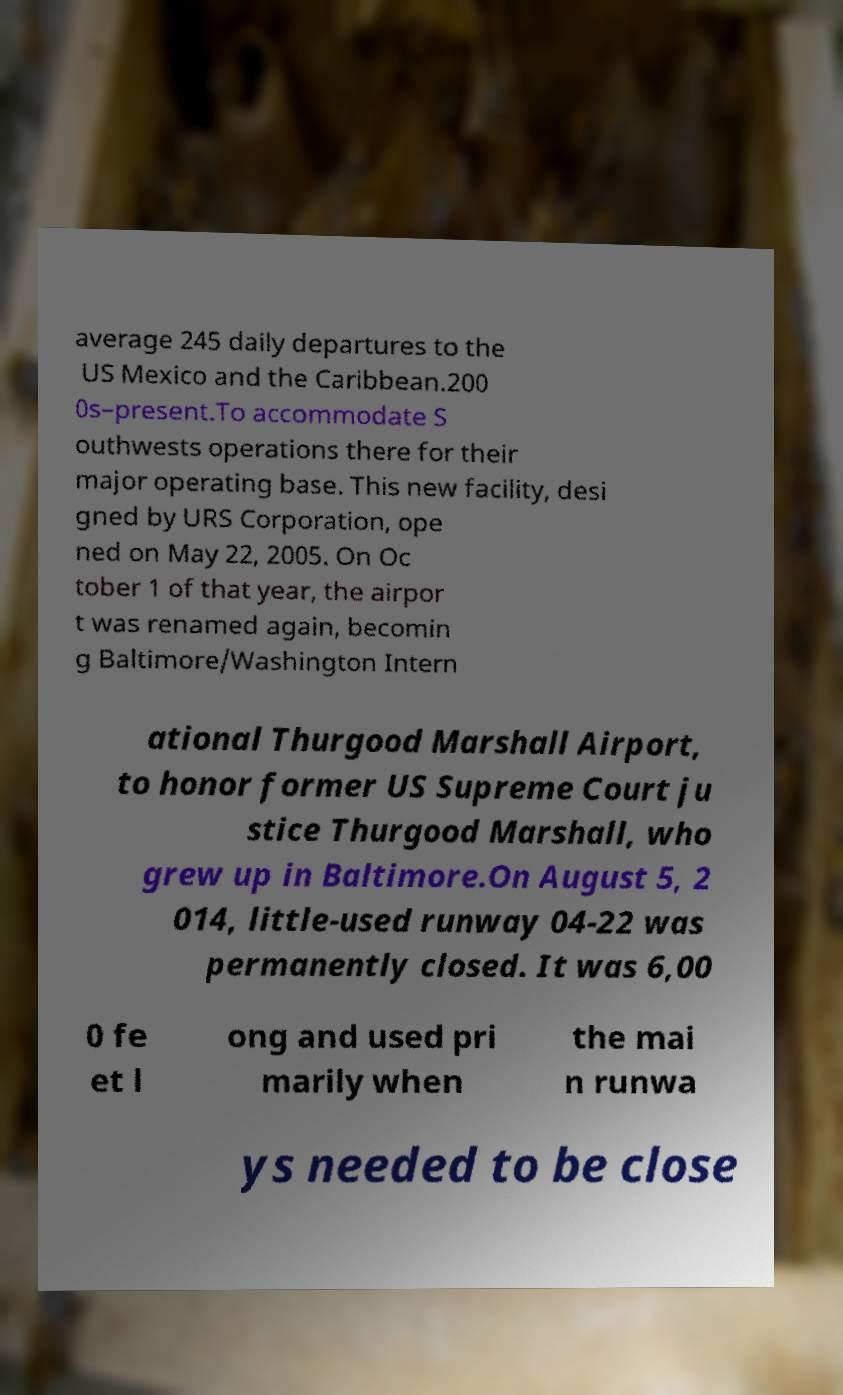Can you accurately transcribe the text from the provided image for me? average 245 daily departures to the US Mexico and the Caribbean.200 0s–present.To accommodate S outhwests operations there for their major operating base. This new facility, desi gned by URS Corporation, ope ned on May 22, 2005. On Oc tober 1 of that year, the airpor t was renamed again, becomin g Baltimore/Washington Intern ational Thurgood Marshall Airport, to honor former US Supreme Court ju stice Thurgood Marshall, who grew up in Baltimore.On August 5, 2 014, little-used runway 04-22 was permanently closed. It was 6,00 0 fe et l ong and used pri marily when the mai n runwa ys needed to be close 